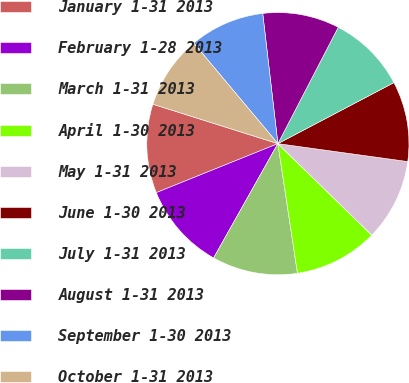Convert chart. <chart><loc_0><loc_0><loc_500><loc_500><pie_chart><fcel>January 1-31 2013<fcel>February 1-28 2013<fcel>March 1-31 2013<fcel>April 1-30 2013<fcel>May 1-31 2013<fcel>June 1-30 2013<fcel>July 1-31 2013<fcel>August 1-31 2013<fcel>September 1-30 2013<fcel>October 1-31 2013<nl><fcel>10.96%<fcel>10.75%<fcel>10.54%<fcel>10.32%<fcel>10.11%<fcel>9.89%<fcel>9.68%<fcel>9.46%<fcel>9.25%<fcel>9.04%<nl></chart> 